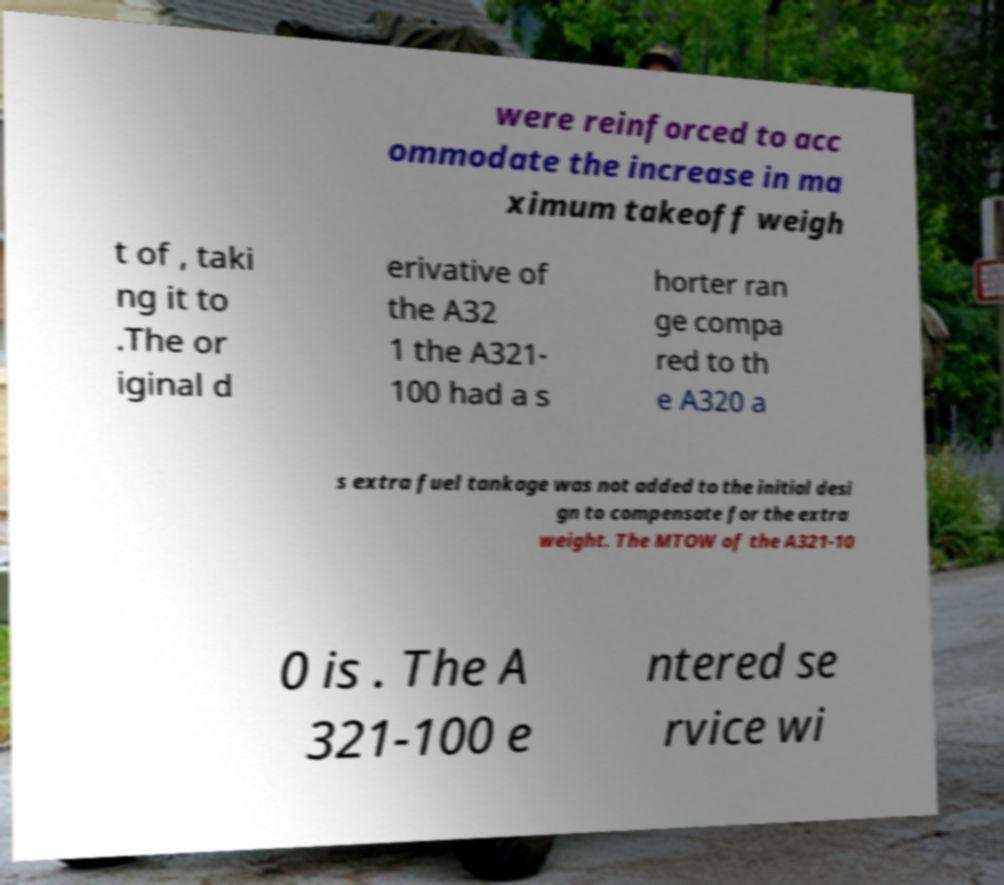There's text embedded in this image that I need extracted. Can you transcribe it verbatim? were reinforced to acc ommodate the increase in ma ximum takeoff weigh t of , taki ng it to .The or iginal d erivative of the A32 1 the A321- 100 had a s horter ran ge compa red to th e A320 a s extra fuel tankage was not added to the initial desi gn to compensate for the extra weight. The MTOW of the A321-10 0 is . The A 321-100 e ntered se rvice wi 